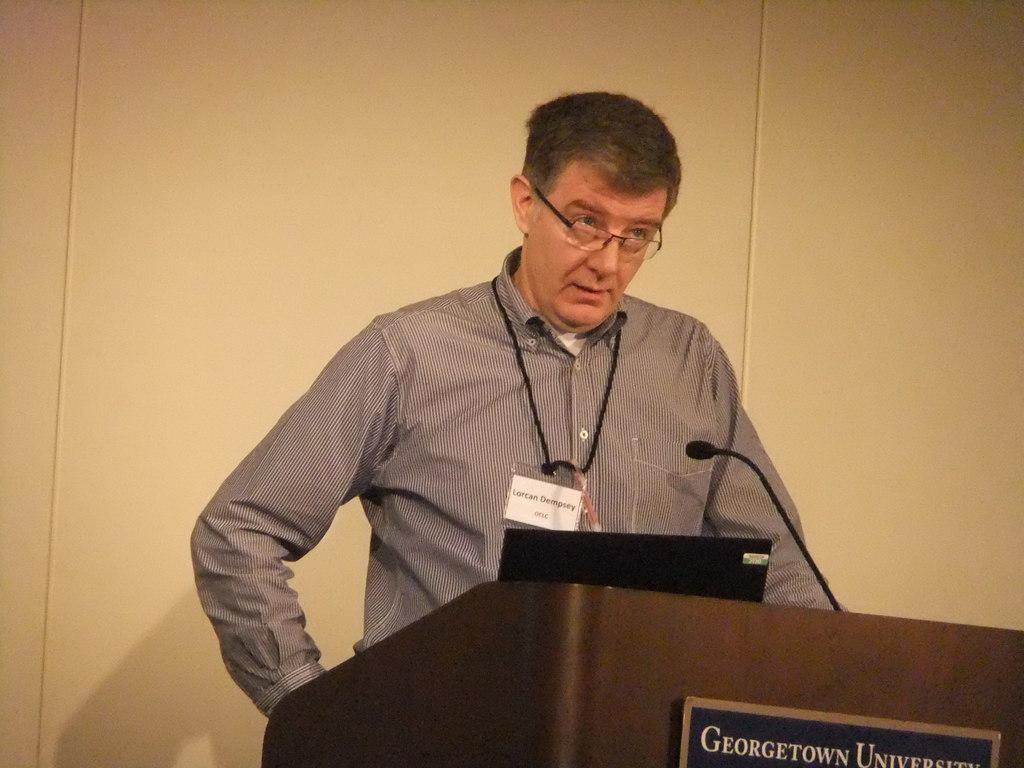In one or two sentences, can you explain what this image depicts? In the image we can see a man standing, wearing clothes, spectacles and he is wearing identity card. In front of him there is a podium, system and microphones. Here we can see the text and the wall. 